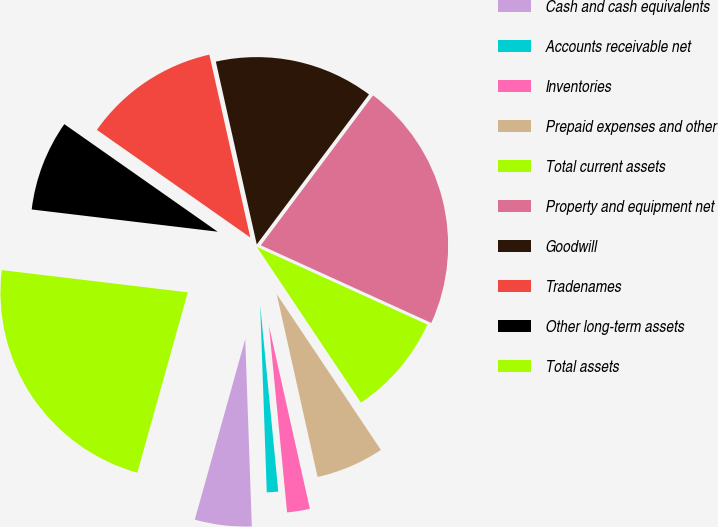Convert chart to OTSL. <chart><loc_0><loc_0><loc_500><loc_500><pie_chart><fcel>Cash and cash equivalents<fcel>Accounts receivable net<fcel>Inventories<fcel>Prepaid expenses and other<fcel>Total current assets<fcel>Property and equipment net<fcel>Goodwill<fcel>Tradenames<fcel>Other long-term assets<fcel>Total assets<nl><fcel>4.9%<fcel>0.98%<fcel>1.96%<fcel>5.88%<fcel>8.82%<fcel>21.57%<fcel>13.73%<fcel>11.76%<fcel>7.84%<fcel>22.55%<nl></chart> 